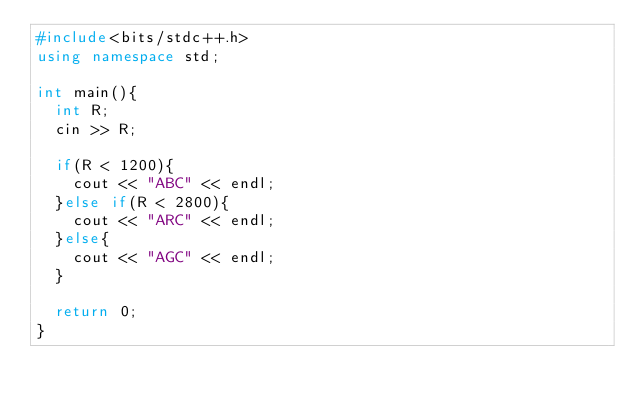<code> <loc_0><loc_0><loc_500><loc_500><_C++_>#include<bits/stdc++.h>
using namespace std;

int main(){
  int R;
  cin >> R;
  
  if(R < 1200){
    cout << "ABC" << endl;
  }else if(R < 2800){
    cout << "ARC" << endl;
  }else{
    cout << "AGC" << endl;
  }

  return 0;
}</code> 